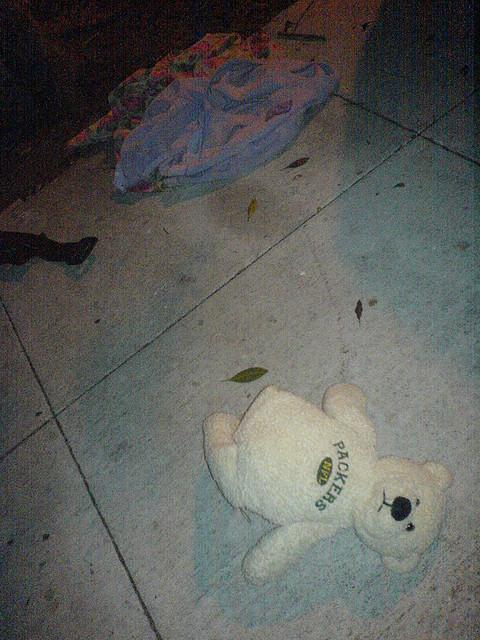What team does the bear represent?
Short answer required. Packers. Is the floor dirty?
Quick response, please. Yes. What is the color of the stuffed toy?
Keep it brief. White. What is on the floor?
Quick response, please. Teddy bear. Is the object floating?
Give a very brief answer. No. What kind of toy is on the ground?
Give a very brief answer. Teddy bear. What is the picture on the right of?
Be succinct. Bear. Which room is this?
Short answer required. Kitchen. What byproduct of this animal is used for clothing?
Quick response, please. Fur. What are the animals placed on?
Give a very brief answer. Floor. Did someone drop a banana on the ground?
Answer briefly. No. What room are these for?
Answer briefly. Bedroom. What are the object on?
Concise answer only. Floor. 